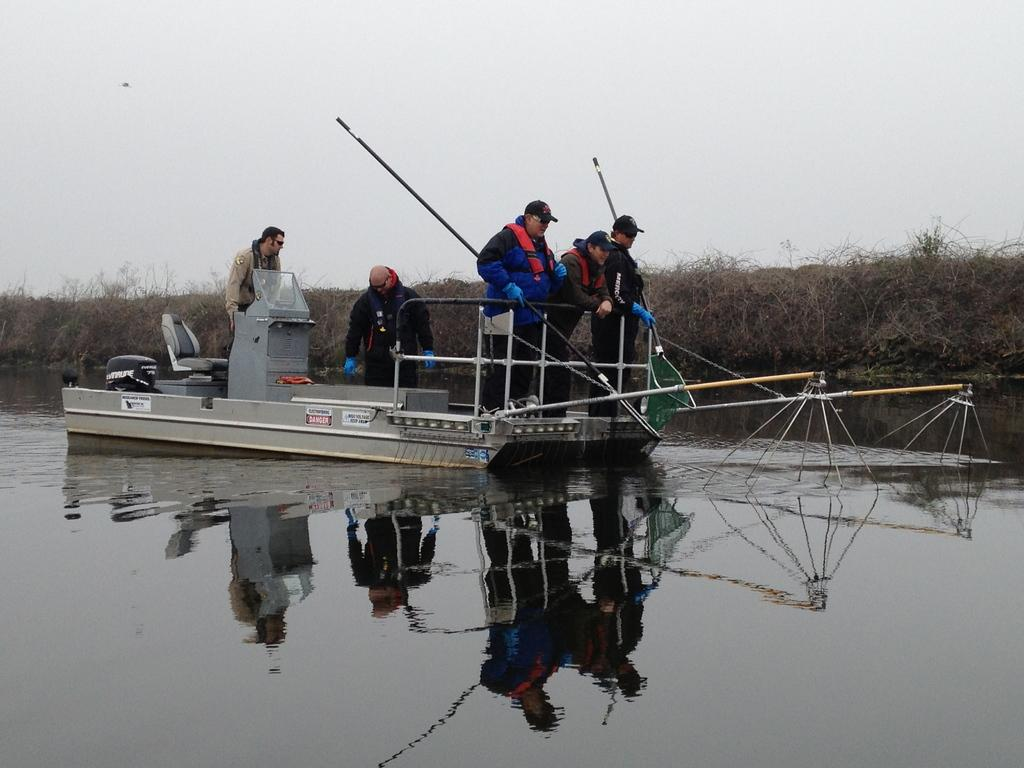How many people are in the boat in the image? There are five persons in a boat in the image. What is visible at the bottom of the image? There is water visible at the bottom of the image. What can be seen in the background of the image? There are plants in the background of the image. What is visible at the top of the image? The sky is visible at the top of the image. What type of celery is being used as a paddle in the image? There is no celery present in the image, and no paddles are visible. 